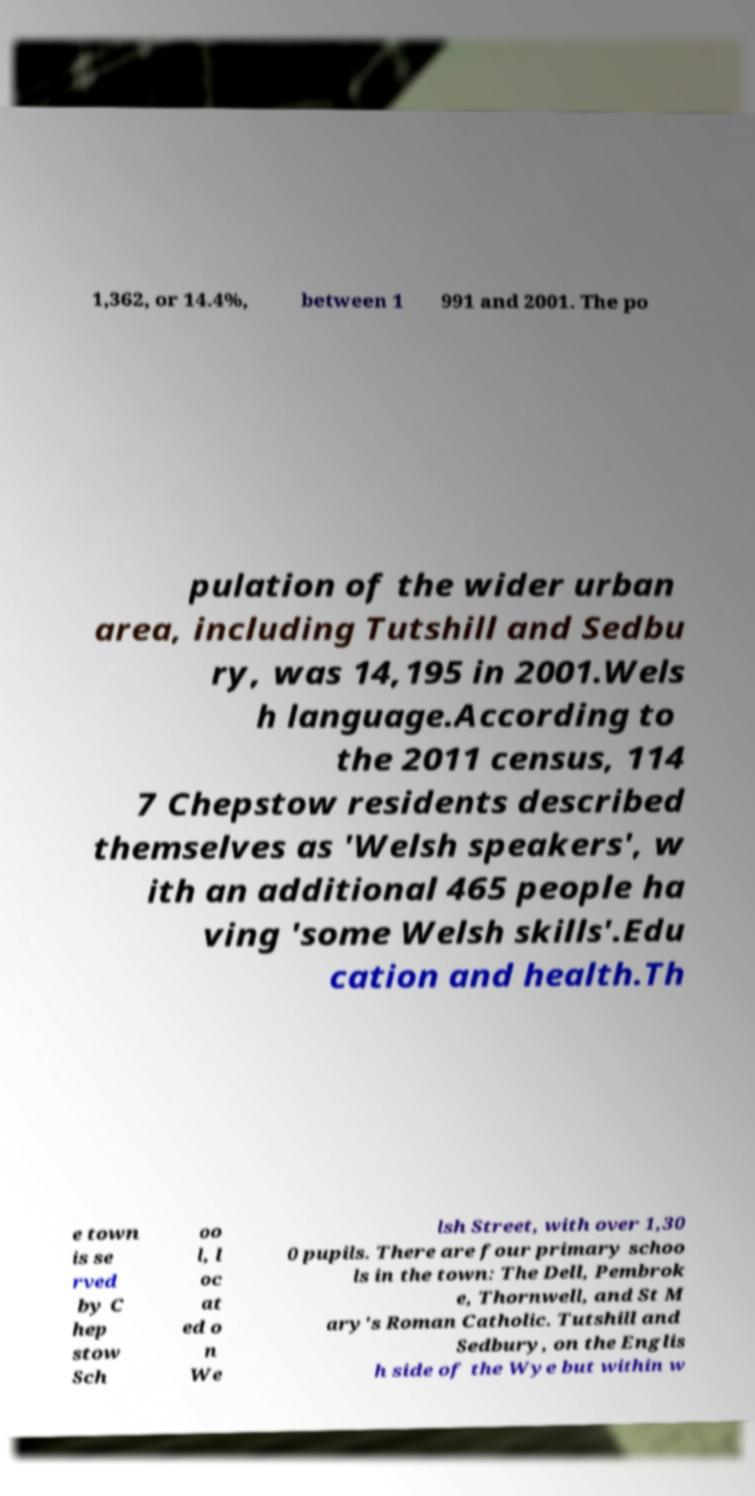I need the written content from this picture converted into text. Can you do that? 1,362, or 14.4%, between 1 991 and 2001. The po pulation of the wider urban area, including Tutshill and Sedbu ry, was 14,195 in 2001.Wels h language.According to the 2011 census, 114 7 Chepstow residents described themselves as 'Welsh speakers', w ith an additional 465 people ha ving 'some Welsh skills'.Edu cation and health.Th e town is se rved by C hep stow Sch oo l, l oc at ed o n We lsh Street, with over 1,30 0 pupils. There are four primary schoo ls in the town: The Dell, Pembrok e, Thornwell, and St M ary's Roman Catholic. Tutshill and Sedbury, on the Englis h side of the Wye but within w 